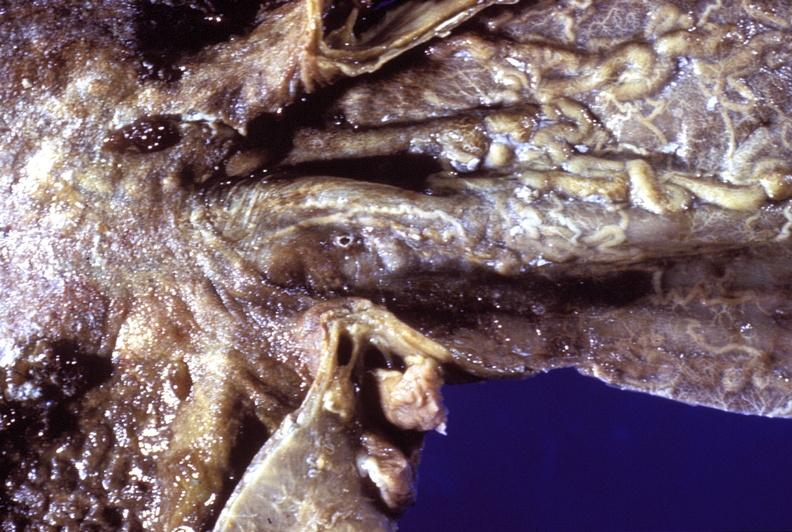s gastrointestinal present?
Answer the question using a single word or phrase. Yes 